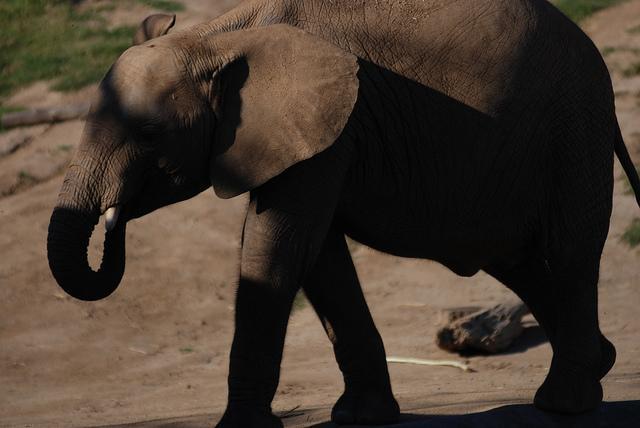How many elephants are there?
Give a very brief answer. 1. 